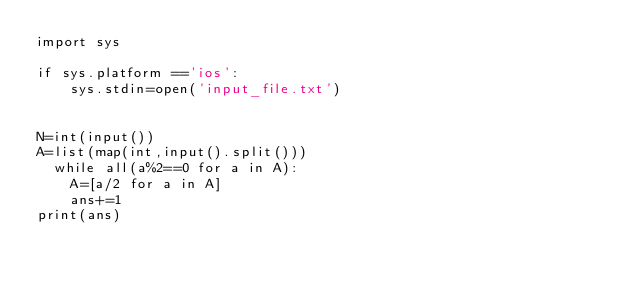Convert code to text. <code><loc_0><loc_0><loc_500><loc_500><_Python_>import sys

if sys.platform =='ios':
    sys.stdin=open('input_file.txt')
    

N=int(input())
A=list(map(int,input().split()))
	while all(a%2==0 for a in A):
		A=[a/2 for a in A]
		ans+=1
print(ans)
		</code> 